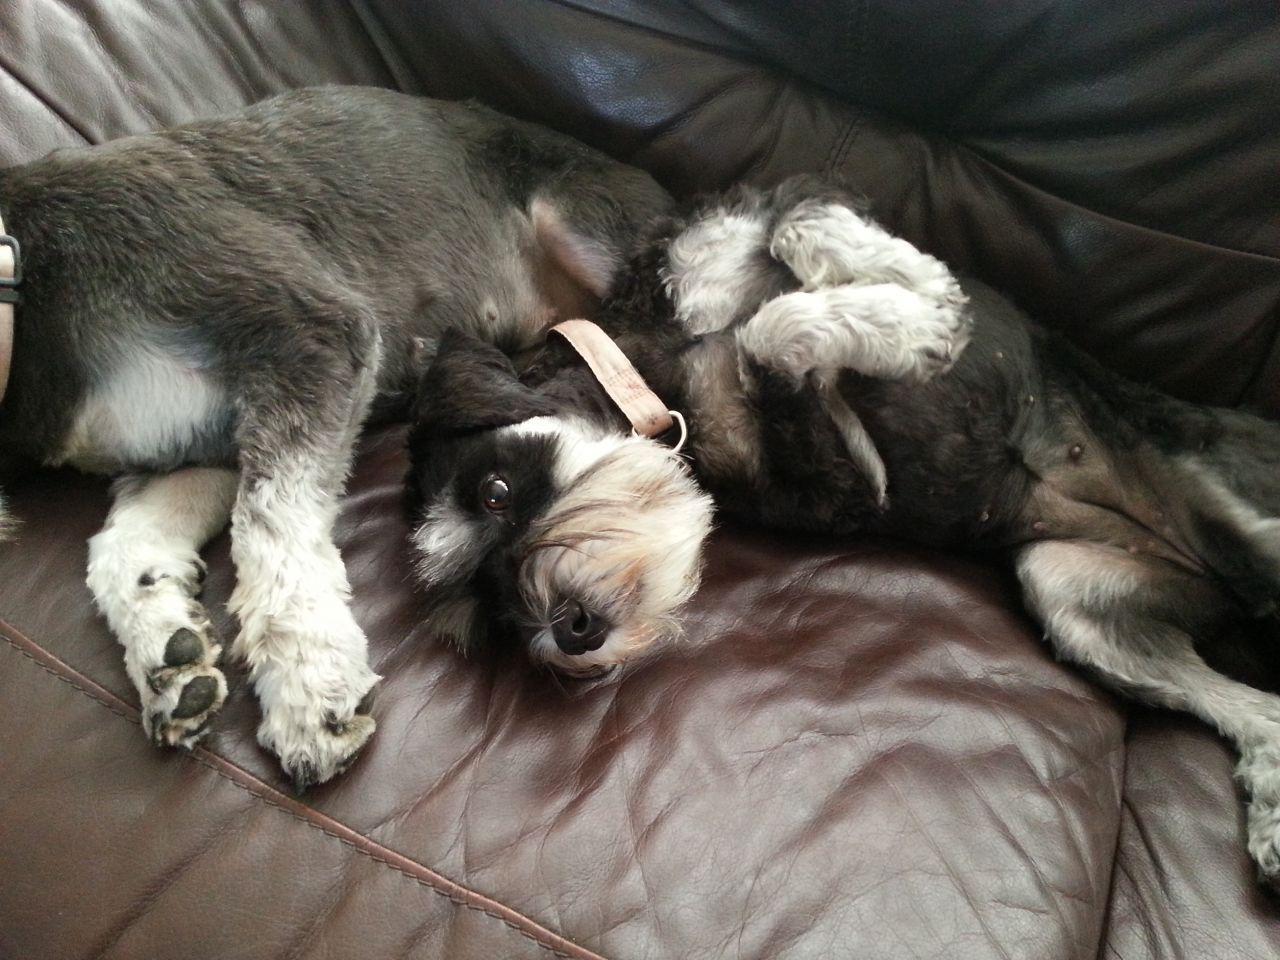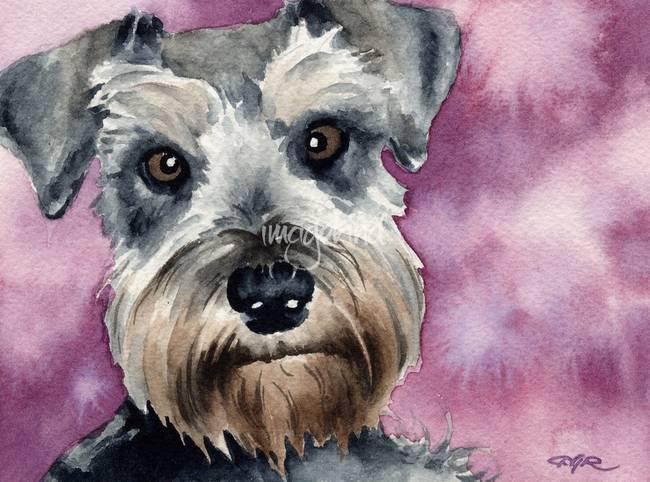The first image is the image on the left, the second image is the image on the right. Evaluate the accuracy of this statement regarding the images: "At least four dogs are visible.". Is it true? Answer yes or no. No. The first image is the image on the left, the second image is the image on the right. Examine the images to the left and right. Is the description "A puppy is standing up, and an adult dog is lying down." accurate? Answer yes or no. No. 